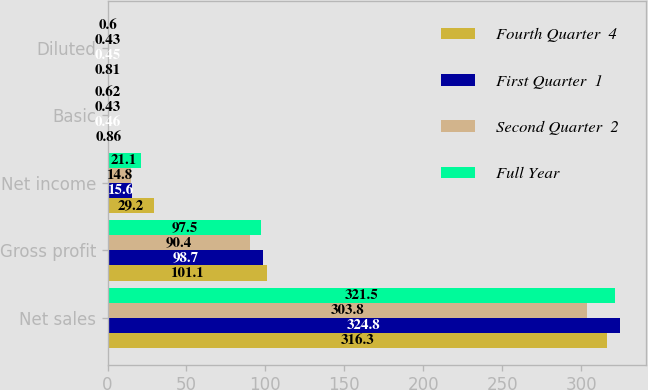Convert chart to OTSL. <chart><loc_0><loc_0><loc_500><loc_500><stacked_bar_chart><ecel><fcel>Net sales<fcel>Gross profit<fcel>Net income<fcel>Basic<fcel>Diluted<nl><fcel>Fourth Quarter  4<fcel>316.3<fcel>101.1<fcel>29.2<fcel>0.86<fcel>0.81<nl><fcel>First Quarter  1<fcel>324.8<fcel>98.7<fcel>15.6<fcel>0.46<fcel>0.45<nl><fcel>Second Quarter  2<fcel>303.8<fcel>90.4<fcel>14.8<fcel>0.43<fcel>0.43<nl><fcel>Full Year<fcel>321.5<fcel>97.5<fcel>21.1<fcel>0.62<fcel>0.6<nl></chart> 